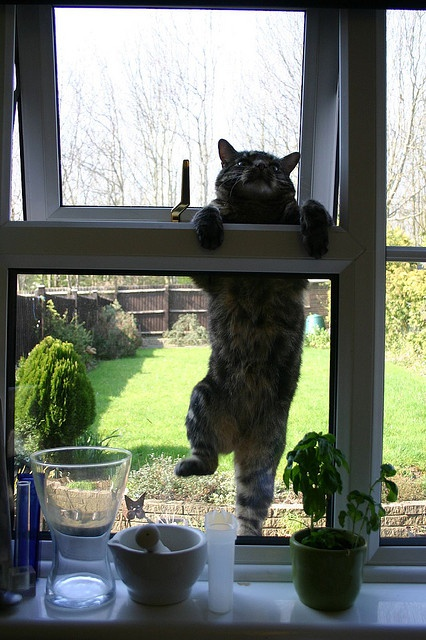Describe the objects in this image and their specific colors. I can see cat in black, gray, and white tones, potted plant in black, darkgreen, and gray tones, cup in black, gray, darkgray, and darkblue tones, potted plant in black, darkgreen, and olive tones, and bowl in black, blue, and darkblue tones in this image. 